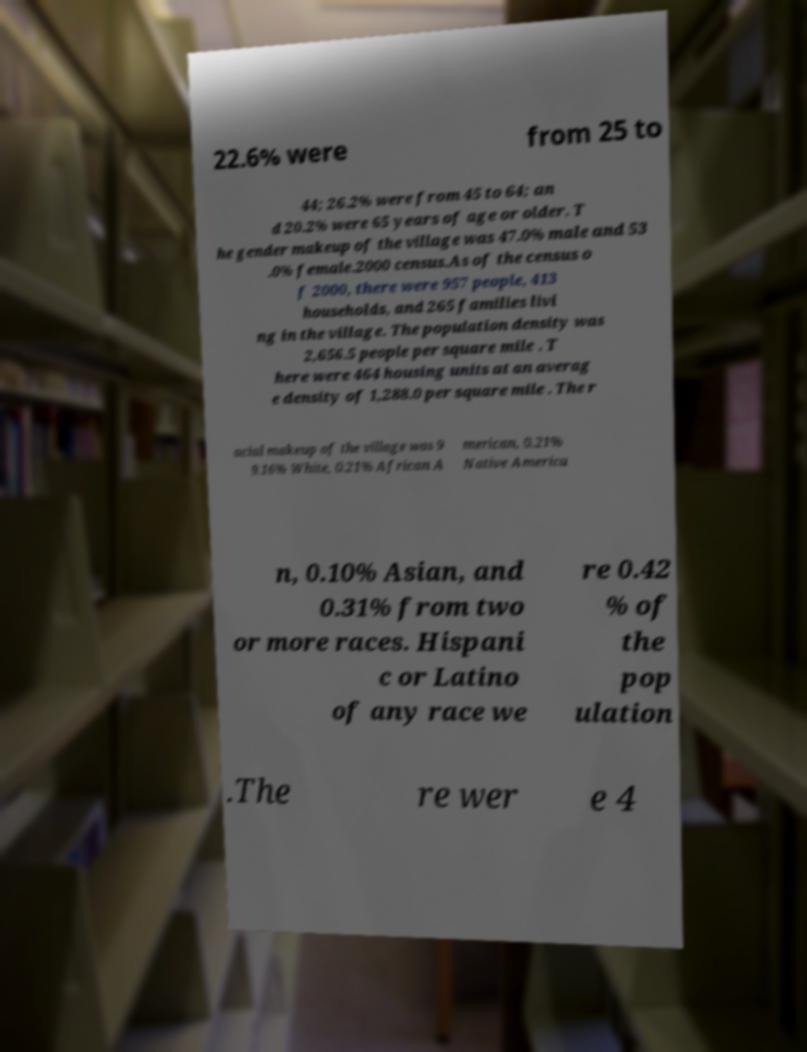I need the written content from this picture converted into text. Can you do that? 22.6% were from 25 to 44; 26.2% were from 45 to 64; an d 20.2% were 65 years of age or older. T he gender makeup of the village was 47.0% male and 53 .0% female.2000 census.As of the census o f 2000, there were 957 people, 413 households, and 265 families livi ng in the village. The population density was 2,656.5 people per square mile . T here were 464 housing units at an averag e density of 1,288.0 per square mile . The r acial makeup of the village was 9 9.16% White, 0.21% African A merican, 0.21% Native America n, 0.10% Asian, and 0.31% from two or more races. Hispani c or Latino of any race we re 0.42 % of the pop ulation .The re wer e 4 